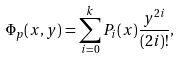<formula> <loc_0><loc_0><loc_500><loc_500>\Phi _ { p } ( x , y ) = \sum _ { i = 0 } ^ { k } P _ { i } ( x ) \frac { y ^ { 2 i } } { ( 2 i ) ! } ,</formula> 